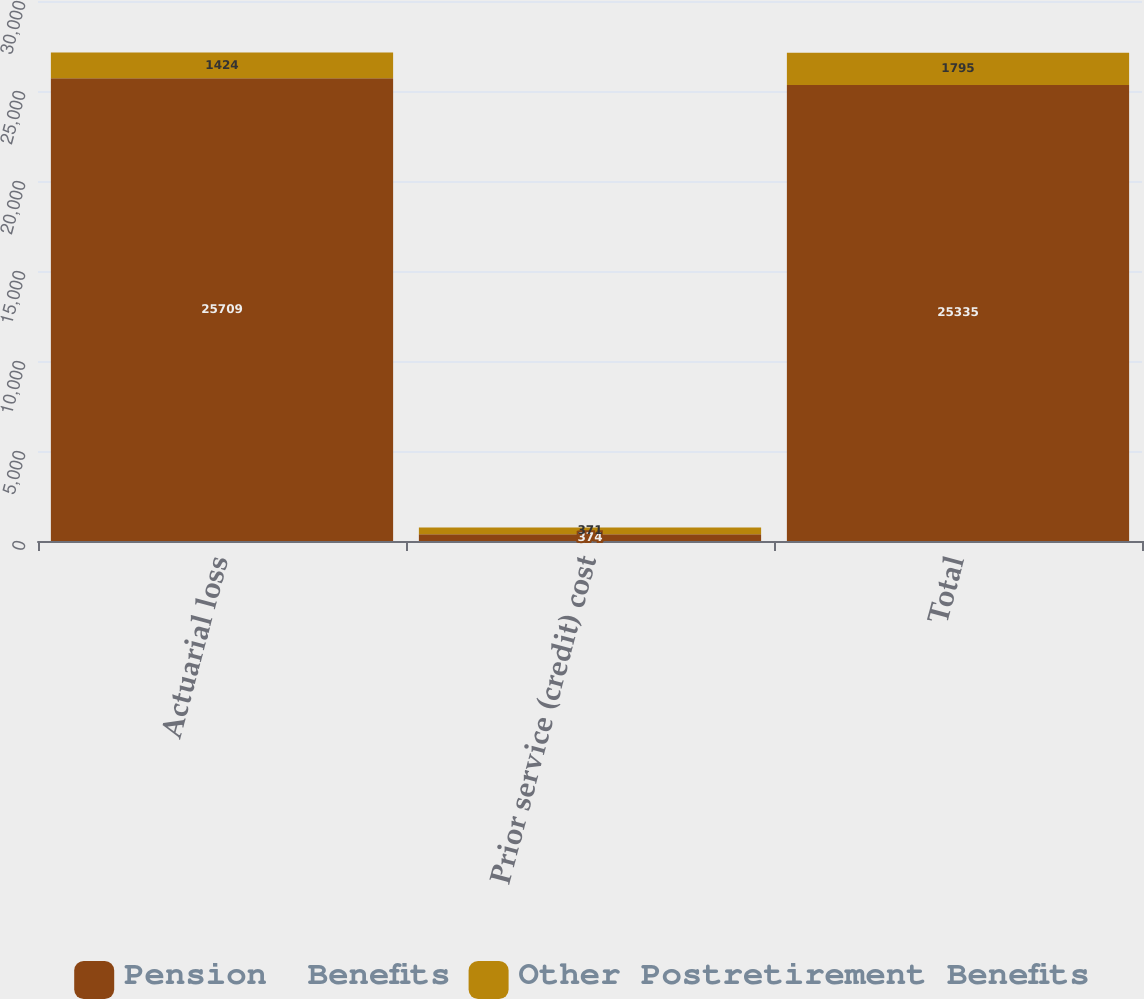<chart> <loc_0><loc_0><loc_500><loc_500><stacked_bar_chart><ecel><fcel>Actuarial loss<fcel>Prior service (credit) cost<fcel>Total<nl><fcel>Pension  Benefits<fcel>25709<fcel>374<fcel>25335<nl><fcel>Other Postretirement Benefits<fcel>1424<fcel>371<fcel>1795<nl></chart> 